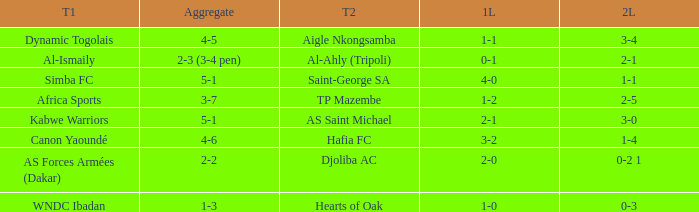What team played against Hafia FC (team 2)? Canon Yaoundé. Would you mind parsing the complete table? {'header': ['T1', 'Aggregate', 'T2', '1L', '2L'], 'rows': [['Dynamic Togolais', '4-5', 'Aigle Nkongsamba', '1-1', '3-4'], ['Al-Ismaily', '2-3 (3-4 pen)', 'Al-Ahly (Tripoli)', '0-1', '2-1'], ['Simba FC', '5-1', 'Saint-George SA', '4-0', '1-1'], ['Africa Sports', '3-7', 'TP Mazembe', '1-2', '2-5'], ['Kabwe Warriors', '5-1', 'AS Saint Michael', '2-1', '3-0'], ['Canon Yaoundé', '4-6', 'Hafia FC', '3-2', '1-4'], ['AS Forces Armées (Dakar)', '2-2', 'Djoliba AC', '2-0', '0-2 1'], ['WNDC Ibadan', '1-3', 'Hearts of Oak', '1-0', '0-3']]} 